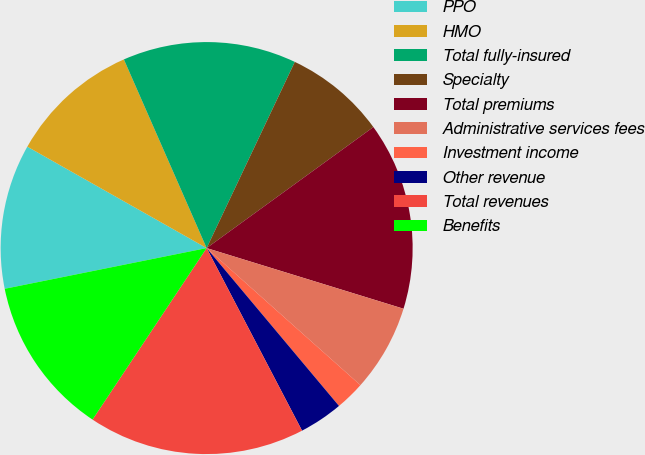Convert chart. <chart><loc_0><loc_0><loc_500><loc_500><pie_chart><fcel>PPO<fcel>HMO<fcel>Total fully-insured<fcel>Specialty<fcel>Total premiums<fcel>Administrative services fees<fcel>Investment income<fcel>Other revenue<fcel>Total revenues<fcel>Benefits<nl><fcel>11.36%<fcel>10.23%<fcel>13.62%<fcel>7.97%<fcel>14.75%<fcel>6.83%<fcel>2.31%<fcel>3.44%<fcel>17.01%<fcel>12.49%<nl></chart> 